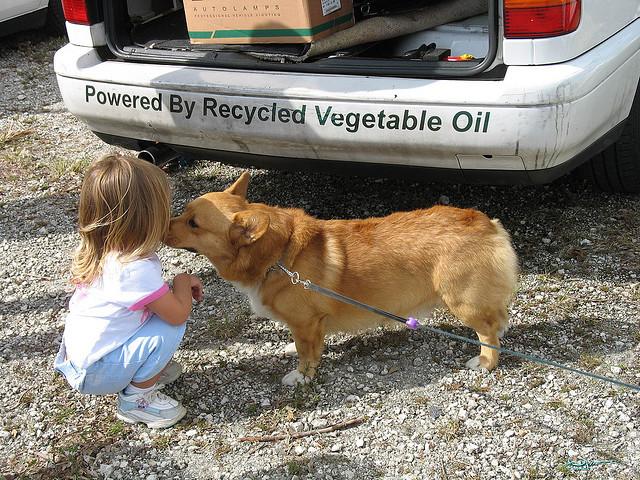Is the dog on a leash?
Keep it brief. Yes. What is the baby sitting in?
Quick response, please. Ground. What breed is the dog?
Be succinct. Corgi. Does this car likely guzzle gasoline?
Quick response, please. No. What kind of dog is this?
Short answer required. Corgi. 